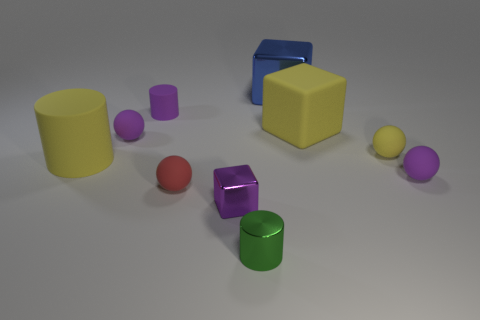Subtract all green spheres. Subtract all purple cylinders. How many spheres are left? 4 Subtract all cylinders. How many objects are left? 7 Add 1 balls. How many balls are left? 5 Add 9 small purple metal cubes. How many small purple metal cubes exist? 10 Subtract 0 red cylinders. How many objects are left? 10 Subtract all big gray shiny things. Subtract all purple blocks. How many objects are left? 9 